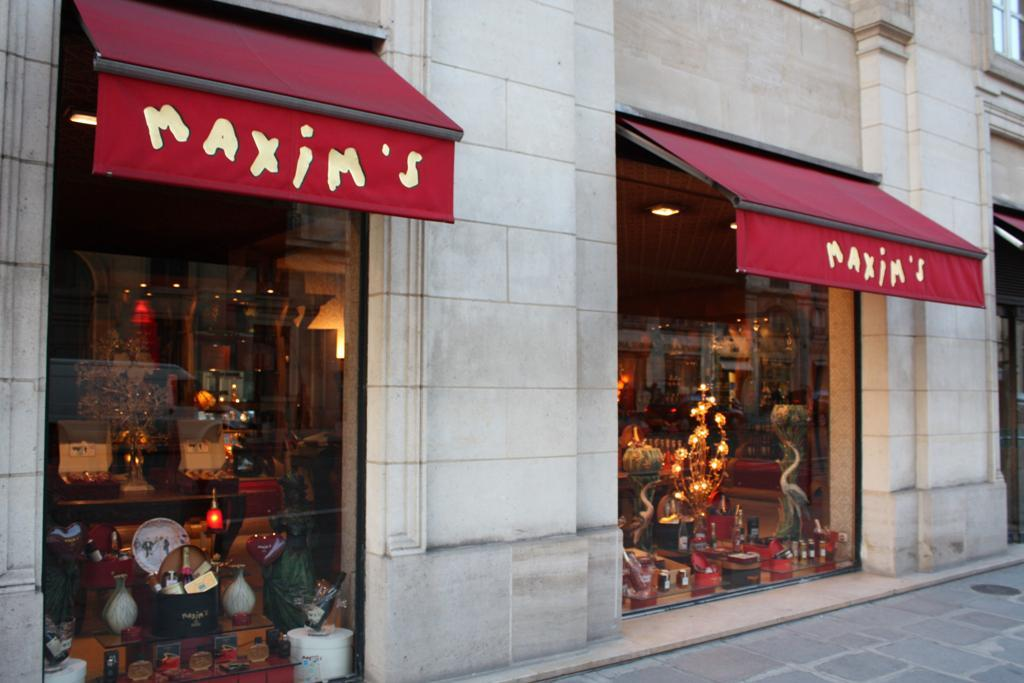What type of walls are present in the middle of the image? There are glass walls in the middle of the image. What can be seen through the glass walls? There are things visible inside the glass walls. Are there any visible light sources inside the glass walls? Yes, there are lights visible inside the glass walls. What does the scene depicted inside the glass walls resemble? The scene resembles a store. What type of brick is used to construct the lift in the image? There is no lift present in the image, so it is not possible to determine the type of brick used for its construction. 